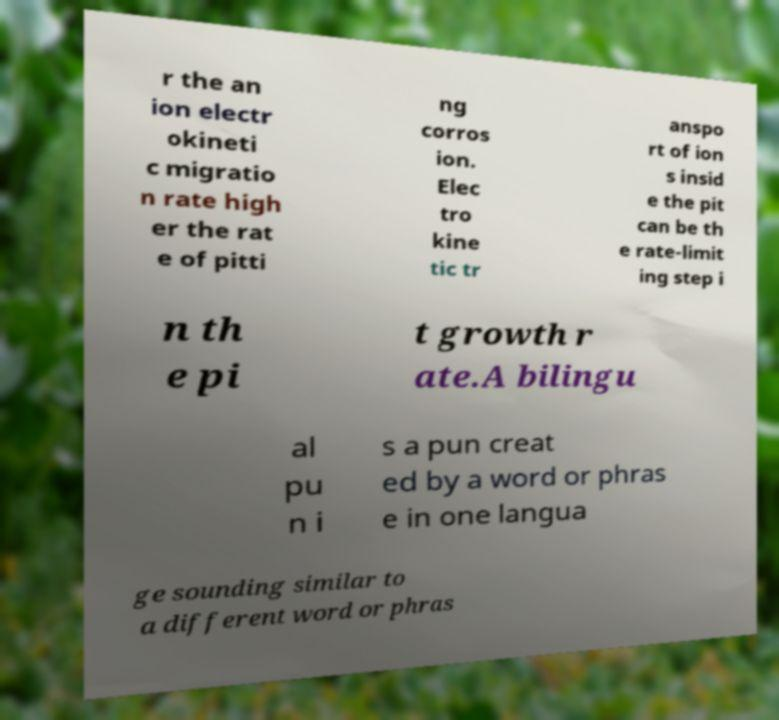Could you extract and type out the text from this image? r the an ion electr okineti c migratio n rate high er the rat e of pitti ng corros ion. Elec tro kine tic tr anspo rt of ion s insid e the pit can be th e rate-limit ing step i n th e pi t growth r ate.A bilingu al pu n i s a pun creat ed by a word or phras e in one langua ge sounding similar to a different word or phras 